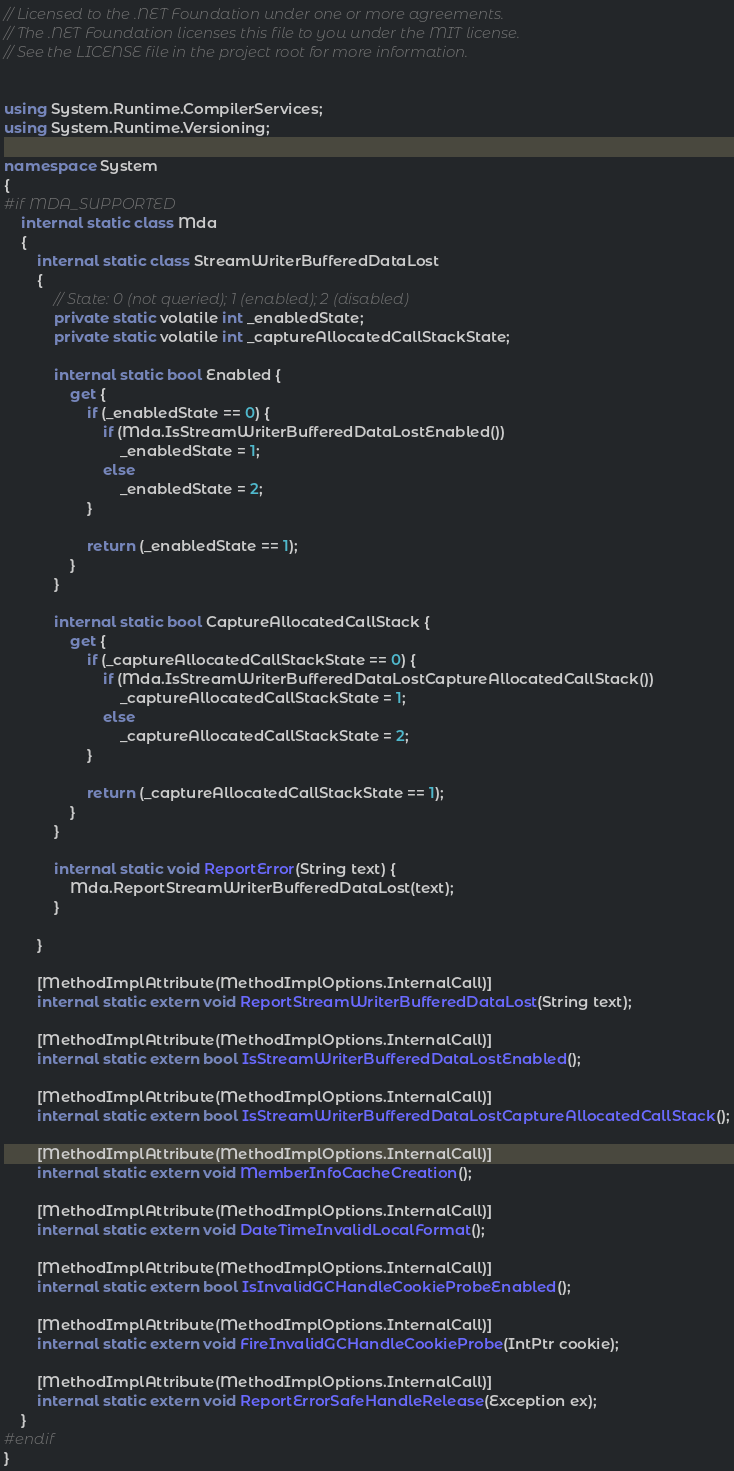<code> <loc_0><loc_0><loc_500><loc_500><_C#_>// Licensed to the .NET Foundation under one or more agreements.
// The .NET Foundation licenses this file to you under the MIT license.
// See the LICENSE file in the project root for more information.


using System.Runtime.CompilerServices;
using System.Runtime.Versioning;

namespace System
{
#if MDA_SUPPORTED
    internal static class Mda
    {
        internal static class StreamWriterBufferedDataLost
        {
            // State: 0 (not queried); 1 (enabled); 2 (disabled)
            private static volatile int _enabledState;
            private static volatile int _captureAllocatedCallStackState;

            internal static bool Enabled {
                get {
                    if (_enabledState == 0) {
                        if (Mda.IsStreamWriterBufferedDataLostEnabled())
                            _enabledState = 1;
                        else
                            _enabledState = 2;
                    }

                    return (_enabledState == 1);
                }
            }

            internal static bool CaptureAllocatedCallStack {
                get {
                    if (_captureAllocatedCallStackState == 0) {
                        if (Mda.IsStreamWriterBufferedDataLostCaptureAllocatedCallStack())
                            _captureAllocatedCallStackState = 1;
                        else
                            _captureAllocatedCallStackState = 2;
                    }

                    return (_captureAllocatedCallStackState == 1);
                }
            }

            internal static void ReportError(String text) {
                Mda.ReportStreamWriterBufferedDataLost(text);
            }

        }

        [MethodImplAttribute(MethodImplOptions.InternalCall)]
        internal static extern void ReportStreamWriterBufferedDataLost(String text);

        [MethodImplAttribute(MethodImplOptions.InternalCall)]
        internal static extern bool IsStreamWriterBufferedDataLostEnabled();

        [MethodImplAttribute(MethodImplOptions.InternalCall)]
        internal static extern bool IsStreamWriterBufferedDataLostCaptureAllocatedCallStack();

        [MethodImplAttribute(MethodImplOptions.InternalCall)]
        internal static extern void MemberInfoCacheCreation();

        [MethodImplAttribute(MethodImplOptions.InternalCall)]
        internal static extern void DateTimeInvalidLocalFormat();

        [MethodImplAttribute(MethodImplOptions.InternalCall)]
        internal static extern bool IsInvalidGCHandleCookieProbeEnabled();

        [MethodImplAttribute(MethodImplOptions.InternalCall)]
        internal static extern void FireInvalidGCHandleCookieProbe(IntPtr cookie);

        [MethodImplAttribute(MethodImplOptions.InternalCall)]
        internal static extern void ReportErrorSafeHandleRelease(Exception ex);
    }
#endif
}
</code> 